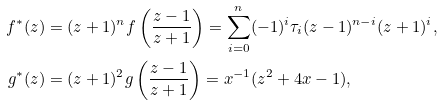Convert formula to latex. <formula><loc_0><loc_0><loc_500><loc_500>f ^ { * } ( z ) & = ( z + 1 ) ^ { n } f \left ( \frac { z - 1 } { z + 1 } \right ) = \sum _ { i = 0 } ^ { n } ( - 1 ) ^ { i } \tau _ { i } ( z - 1 ) ^ { n - i } ( z + 1 ) ^ { i } , \\ g ^ { * } ( z ) & = ( z + 1 ) ^ { 2 } g \left ( \frac { z - 1 } { z + 1 } \right ) = x ^ { - 1 } ( z ^ { 2 } + 4 x - 1 ) ,</formula> 